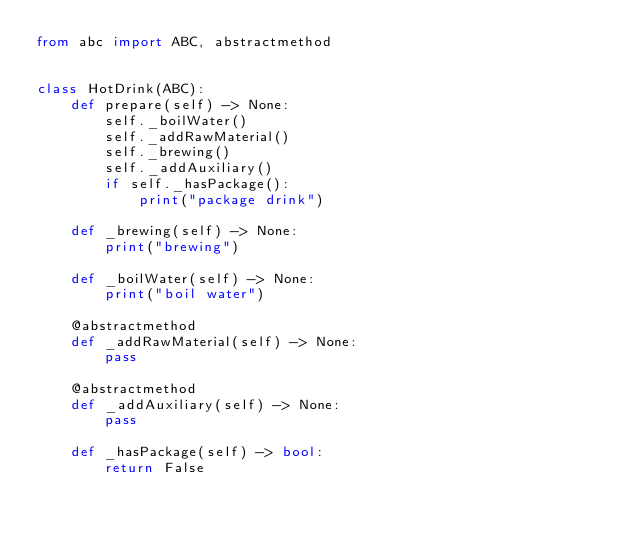<code> <loc_0><loc_0><loc_500><loc_500><_Python_>from abc import ABC, abstractmethod


class HotDrink(ABC):
    def prepare(self) -> None:
        self._boilWater()
        self._addRawMaterial()
        self._brewing()
        self._addAuxiliary()
        if self._hasPackage():
            print("package drink")

    def _brewing(self) -> None:
        print("brewing")

    def _boilWater(self) -> None:
        print("boil water")

    @abstractmethod
    def _addRawMaterial(self) -> None:
        pass

    @abstractmethod
    def _addAuxiliary(self) -> None:
        pass

    def _hasPackage(self) -> bool:
        return False
</code> 